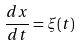Convert formula to latex. <formula><loc_0><loc_0><loc_500><loc_500>\frac { d x } { d t } = \xi ( t )</formula> 